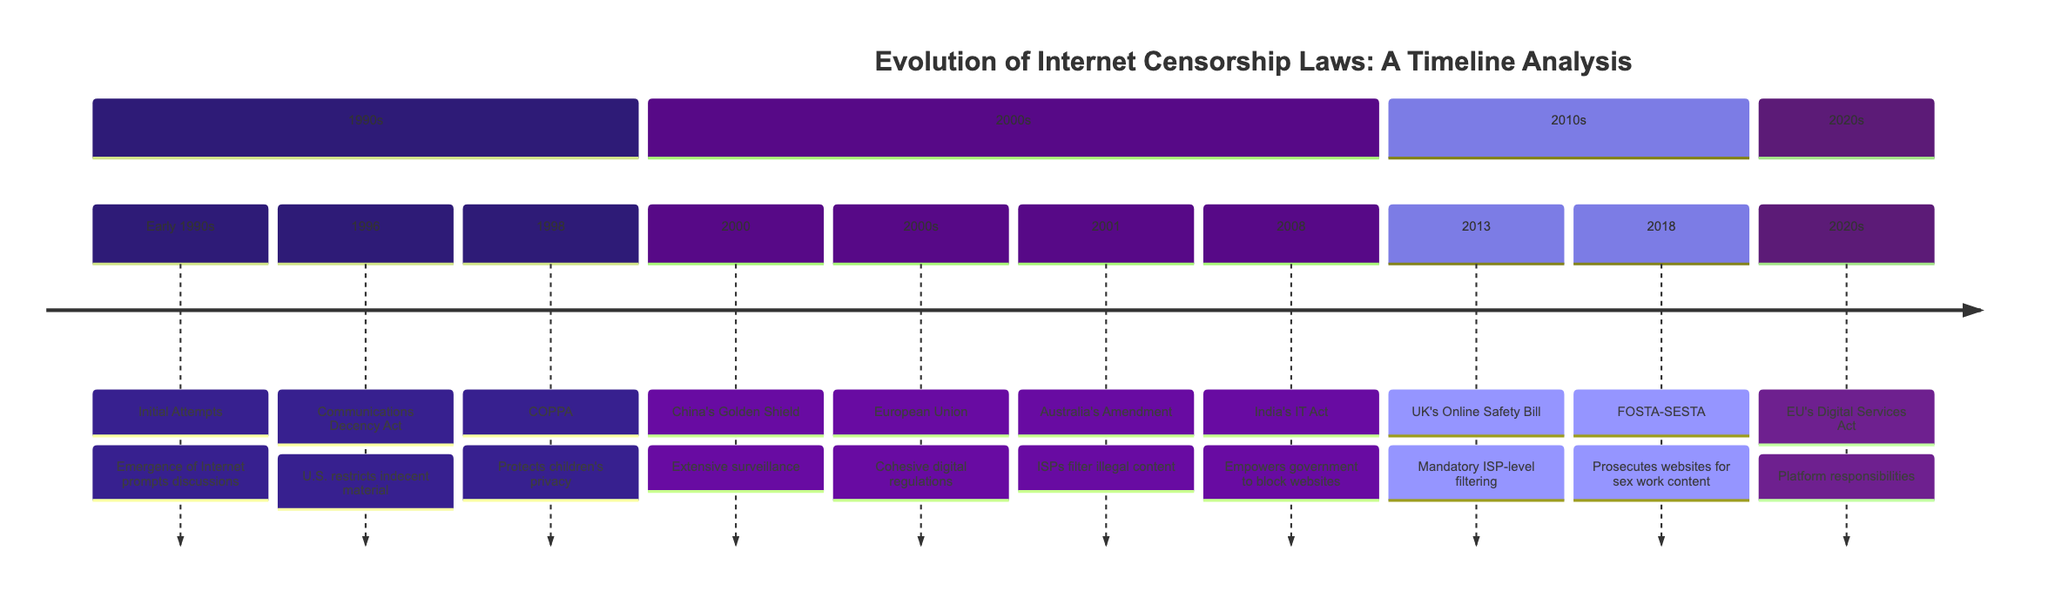What year was the Communications Decency Act enacted? The Communications Decency Act was listed under the section for the 1990s, specifically in 1996. Therefore, the year of enactment is 1996.
Answer: 1996 How many laws are documented in the 2000s section? The section for the 2000s includes four laws: China's Golden Shield, European Union regulations, Australia's Amendment, and India's IT Act. This totals four laws in that section.
Answer: 4 What law followed the UK's Online Safety Bill? The UK's Online Safety Bill was enacted in 2013, and the next law listed, which follows it, is FOSTA-SESTA, enacted in 2018.
Answer: FOSTA-SESTA Which act was introduced in 2020? The diagram includes the EU's Digital Services Act under the 2020s section. Therefore, the act introduced in 2020 is the Digital Services Act.
Answer: Digital Services Act What was the primary focus of COPPA? COPPA, mentioned in 1998, focuses on protecting children's privacy online. This is the primary focus indicated in the timeline.
Answer: Protects children's privacy 